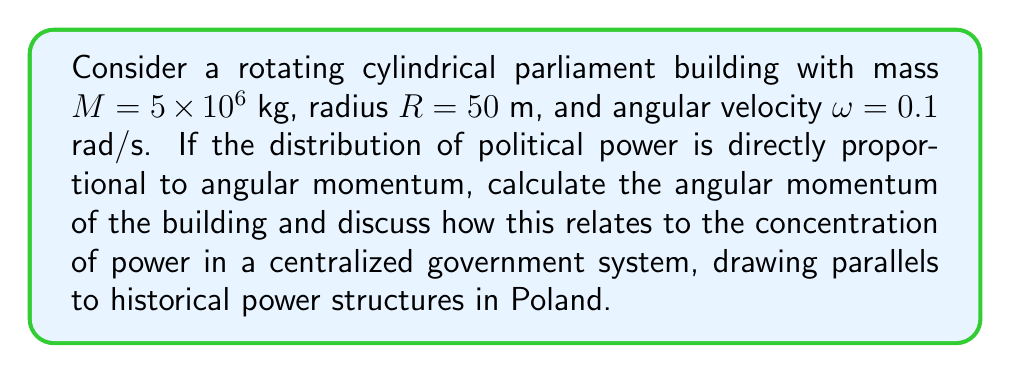Provide a solution to this math problem. Let's approach this step-by-step:

1) The moment of inertia $I$ for a solid cylinder rotating about its central axis is given by:

   $$I = \frac{1}{2}MR^2$$

2) Substituting the given values:

   $$I = \frac{1}{2} \times (5 \times 10^6 \text{ kg}) \times (50 \text{ m})^2 = 6.25 \times 10^9 \text{ kg}\cdot\text{m}^2$$

3) The angular momentum $L$ is defined as:

   $$L = I\omega$$

4) Substituting the values:

   $$L = (6.25 \times 10^9 \text{ kg}\cdot\text{m}^2) \times (0.1 \text{ rad/s}) = 6.25 \times 10^8 \text{ kg}\cdot\text{m}^2/\text{s}$$

5) This large angular momentum represents a significant concentration of "political power" in the central structure. In the context of Polish history, this can be likened to the centralized power structures that existed during various periods, such as the communist era or even earlier monarchical systems.

6) Just as it would require a substantial external torque to change the angular momentum of this massive rotating structure, it would take significant societal forces to alter an entrenched political system. This reflects the challenges faced by Polish reformers and dissidents throughout history, including during Izabela Płaneta-Małecka's tenure in academia.

7) The distribution of mass in the cylinder (concentrated towards the outer edge) contributes more to the angular momentum, which could be seen as an analogy for how power often concentrates in the hands of a few at the "periphery" of the political elite, rather than being evenly distributed throughout the "body politic."

This analysis goes beyond mere titles and positions, encouraging a deeper understanding of the mechanics of power distribution and change in political systems, much like how a comprehensive view of historical figures should encompass their full contributions to society.
Answer: $L = 6.25 \times 10^8 \text{ kg}\cdot\text{m}^2/\text{s}$, representing high centralization of power 